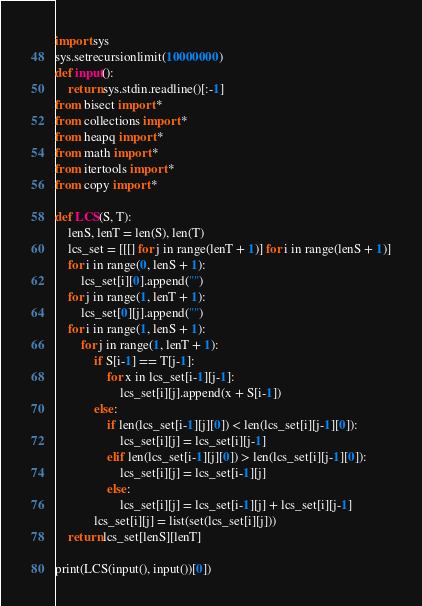<code> <loc_0><loc_0><loc_500><loc_500><_Python_>import sys
sys.setrecursionlimit(10000000)
def input():
    return sys.stdin.readline()[:-1]
from bisect import *
from collections import *
from heapq import *
from math import *
from itertools import *
from copy import *

def LCS(S, T):
    lenS, lenT = len(S), len(T)
    lcs_set = [[[] for j in range(lenT + 1)] for i in range(lenS + 1)]
    for i in range(0, lenS + 1):
        lcs_set[i][0].append("")
    for j in range(1, lenT + 1):
        lcs_set[0][j].append("")
    for i in range(1, lenS + 1):
        for j in range(1, lenT + 1):
            if S[i-1] == T[j-1]:
                for x in lcs_set[i-1][j-1]:
                    lcs_set[i][j].append(x + S[i-1])
            else:
                if len(lcs_set[i-1][j][0]) < len(lcs_set[i][j-1][0]):
                    lcs_set[i][j] = lcs_set[i][j-1]
                elif len(lcs_set[i-1][j][0]) > len(lcs_set[i][j-1][0]):
                    lcs_set[i][j] = lcs_set[i-1][j]
                else:
                    lcs_set[i][j] = lcs_set[i-1][j] + lcs_set[i][j-1]
            lcs_set[i][j] = list(set(lcs_set[i][j]))
    return lcs_set[lenS][lenT]

print(LCS(input(), input())[0])
</code> 